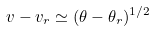<formula> <loc_0><loc_0><loc_500><loc_500>v - v _ { r } \simeq ( \theta - \theta _ { r } ) ^ { 1 / 2 }</formula> 